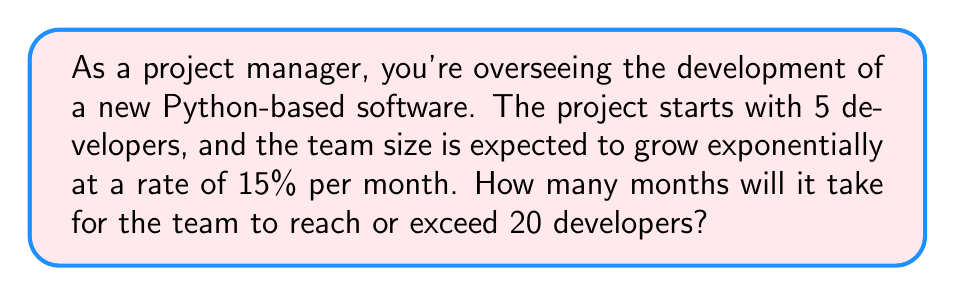Teach me how to tackle this problem. Let's approach this step-by-step using the exponential growth formula:

1) The exponential growth formula is:
   $A = P(1 + r)^t$

   Where:
   $A$ = final amount
   $P$ = initial amount
   $r$ = growth rate (as a decimal)
   $t$ = time

2) We know:
   $P = 5$ (initial team size)
   $r = 0.15$ (15% growth rate)
   $A \geq 20$ (we want to know when the team size reaches or exceeds 20)

3) Let's plug these into our formula:
   $20 \leq 5(1 + 0.15)^t$

4) Divide both sides by 5:
   $4 \leq (1.15)^t$

5) Take the natural log of both sides:
   $\ln(4) \leq t \cdot \ln(1.15)$

6) Solve for $t$:
   $t \geq \frac{\ln(4)}{\ln(1.15)}$

7) Calculate:
   $t \geq \frac{1.3862943611}{0.1397619126} \approx 9.92$

8) Since we can't have a fractional month in this context, we need to round up to the next whole number.
Answer: It will take 10 months for the team to reach or exceed 20 developers. 